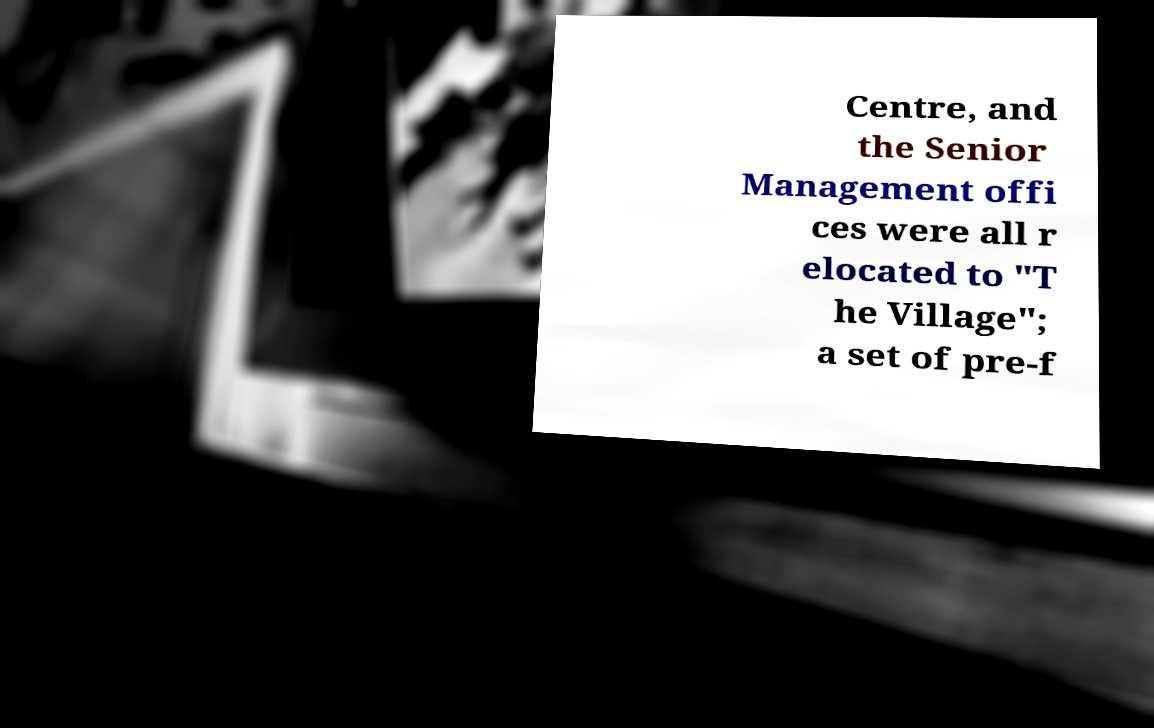I need the written content from this picture converted into text. Can you do that? Centre, and the Senior Management offi ces were all r elocated to "T he Village"; a set of pre-f 